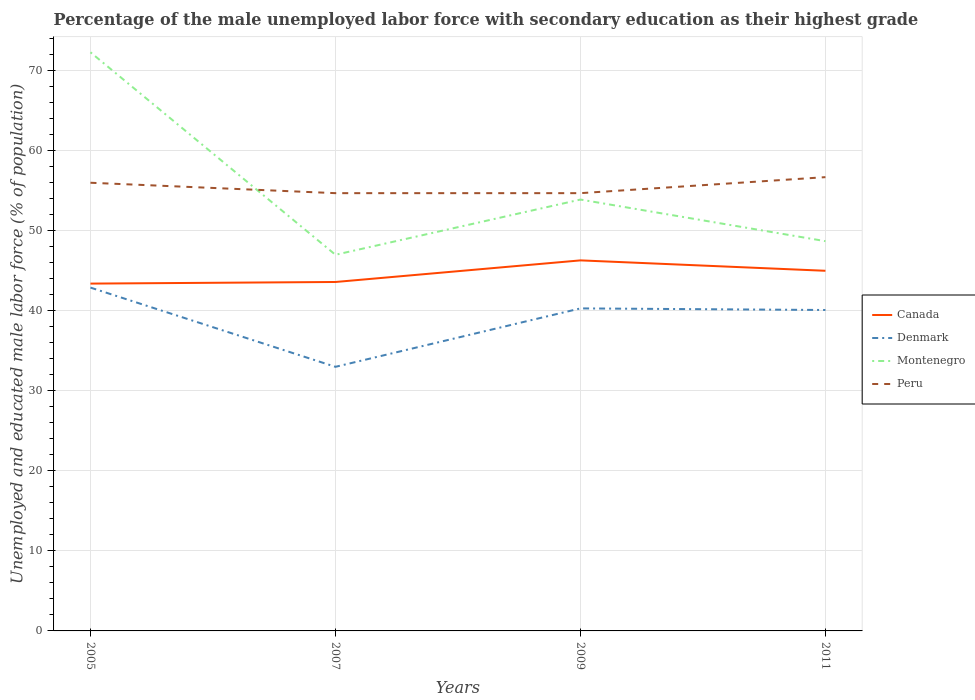Does the line corresponding to Denmark intersect with the line corresponding to Canada?
Give a very brief answer. No. Across all years, what is the maximum percentage of the unemployed male labor force with secondary education in Canada?
Your answer should be compact. 43.4. What is the total percentage of the unemployed male labor force with secondary education in Denmark in the graph?
Offer a very short reply. -7.1. What is the difference between the highest and the second highest percentage of the unemployed male labor force with secondary education in Canada?
Your response must be concise. 2.9. What is the difference between the highest and the lowest percentage of the unemployed male labor force with secondary education in Canada?
Offer a terse response. 2. Is the percentage of the unemployed male labor force with secondary education in Denmark strictly greater than the percentage of the unemployed male labor force with secondary education in Peru over the years?
Your answer should be compact. Yes. How many lines are there?
Provide a short and direct response. 4. What is the difference between two consecutive major ticks on the Y-axis?
Your response must be concise. 10. Does the graph contain grids?
Your answer should be compact. Yes. How many legend labels are there?
Ensure brevity in your answer.  4. What is the title of the graph?
Provide a succinct answer. Percentage of the male unemployed labor force with secondary education as their highest grade. Does "Norway" appear as one of the legend labels in the graph?
Your answer should be compact. No. What is the label or title of the Y-axis?
Your answer should be compact. Unemployed and educated male labor force (% of population). What is the Unemployed and educated male labor force (% of population) of Canada in 2005?
Offer a terse response. 43.4. What is the Unemployed and educated male labor force (% of population) of Denmark in 2005?
Your response must be concise. 42.9. What is the Unemployed and educated male labor force (% of population) of Montenegro in 2005?
Offer a very short reply. 72.3. What is the Unemployed and educated male labor force (% of population) in Canada in 2007?
Keep it short and to the point. 43.6. What is the Unemployed and educated male labor force (% of population) of Denmark in 2007?
Your response must be concise. 33. What is the Unemployed and educated male labor force (% of population) in Montenegro in 2007?
Give a very brief answer. 47. What is the Unemployed and educated male labor force (% of population) of Peru in 2007?
Your answer should be very brief. 54.7. What is the Unemployed and educated male labor force (% of population) in Canada in 2009?
Your answer should be very brief. 46.3. What is the Unemployed and educated male labor force (% of population) of Denmark in 2009?
Your answer should be compact. 40.3. What is the Unemployed and educated male labor force (% of population) of Montenegro in 2009?
Give a very brief answer. 53.9. What is the Unemployed and educated male labor force (% of population) in Peru in 2009?
Make the answer very short. 54.7. What is the Unemployed and educated male labor force (% of population) in Denmark in 2011?
Offer a terse response. 40.1. What is the Unemployed and educated male labor force (% of population) of Montenegro in 2011?
Make the answer very short. 48.7. What is the Unemployed and educated male labor force (% of population) of Peru in 2011?
Make the answer very short. 56.7. Across all years, what is the maximum Unemployed and educated male labor force (% of population) in Canada?
Provide a succinct answer. 46.3. Across all years, what is the maximum Unemployed and educated male labor force (% of population) of Denmark?
Provide a short and direct response. 42.9. Across all years, what is the maximum Unemployed and educated male labor force (% of population) of Montenegro?
Your response must be concise. 72.3. Across all years, what is the maximum Unemployed and educated male labor force (% of population) of Peru?
Make the answer very short. 56.7. Across all years, what is the minimum Unemployed and educated male labor force (% of population) of Canada?
Provide a short and direct response. 43.4. Across all years, what is the minimum Unemployed and educated male labor force (% of population) in Denmark?
Make the answer very short. 33. Across all years, what is the minimum Unemployed and educated male labor force (% of population) in Montenegro?
Give a very brief answer. 47. Across all years, what is the minimum Unemployed and educated male labor force (% of population) of Peru?
Your answer should be very brief. 54.7. What is the total Unemployed and educated male labor force (% of population) in Canada in the graph?
Give a very brief answer. 178.3. What is the total Unemployed and educated male labor force (% of population) of Denmark in the graph?
Provide a succinct answer. 156.3. What is the total Unemployed and educated male labor force (% of population) in Montenegro in the graph?
Ensure brevity in your answer.  221.9. What is the total Unemployed and educated male labor force (% of population) of Peru in the graph?
Your response must be concise. 222.1. What is the difference between the Unemployed and educated male labor force (% of population) of Canada in 2005 and that in 2007?
Your answer should be very brief. -0.2. What is the difference between the Unemployed and educated male labor force (% of population) in Denmark in 2005 and that in 2007?
Offer a very short reply. 9.9. What is the difference between the Unemployed and educated male labor force (% of population) of Montenegro in 2005 and that in 2007?
Provide a succinct answer. 25.3. What is the difference between the Unemployed and educated male labor force (% of population) in Canada in 2005 and that in 2009?
Your response must be concise. -2.9. What is the difference between the Unemployed and educated male labor force (% of population) in Denmark in 2005 and that in 2009?
Ensure brevity in your answer.  2.6. What is the difference between the Unemployed and educated male labor force (% of population) of Montenegro in 2005 and that in 2009?
Provide a short and direct response. 18.4. What is the difference between the Unemployed and educated male labor force (% of population) in Peru in 2005 and that in 2009?
Ensure brevity in your answer.  1.3. What is the difference between the Unemployed and educated male labor force (% of population) of Canada in 2005 and that in 2011?
Offer a very short reply. -1.6. What is the difference between the Unemployed and educated male labor force (% of population) of Denmark in 2005 and that in 2011?
Provide a short and direct response. 2.8. What is the difference between the Unemployed and educated male labor force (% of population) of Montenegro in 2005 and that in 2011?
Your answer should be compact. 23.6. What is the difference between the Unemployed and educated male labor force (% of population) in Canada in 2007 and that in 2009?
Your answer should be compact. -2.7. What is the difference between the Unemployed and educated male labor force (% of population) of Peru in 2007 and that in 2009?
Provide a succinct answer. 0. What is the difference between the Unemployed and educated male labor force (% of population) of Denmark in 2007 and that in 2011?
Your response must be concise. -7.1. What is the difference between the Unemployed and educated male labor force (% of population) in Montenegro in 2007 and that in 2011?
Your response must be concise. -1.7. What is the difference between the Unemployed and educated male labor force (% of population) in Montenegro in 2009 and that in 2011?
Offer a very short reply. 5.2. What is the difference between the Unemployed and educated male labor force (% of population) in Peru in 2009 and that in 2011?
Give a very brief answer. -2. What is the difference between the Unemployed and educated male labor force (% of population) in Canada in 2005 and the Unemployed and educated male labor force (% of population) in Montenegro in 2007?
Your answer should be compact. -3.6. What is the difference between the Unemployed and educated male labor force (% of population) in Canada in 2005 and the Unemployed and educated male labor force (% of population) in Peru in 2007?
Keep it short and to the point. -11.3. What is the difference between the Unemployed and educated male labor force (% of population) in Montenegro in 2005 and the Unemployed and educated male labor force (% of population) in Peru in 2007?
Offer a terse response. 17.6. What is the difference between the Unemployed and educated male labor force (% of population) in Canada in 2005 and the Unemployed and educated male labor force (% of population) in Denmark in 2009?
Ensure brevity in your answer.  3.1. What is the difference between the Unemployed and educated male labor force (% of population) in Canada in 2005 and the Unemployed and educated male labor force (% of population) in Montenegro in 2009?
Offer a very short reply. -10.5. What is the difference between the Unemployed and educated male labor force (% of population) of Denmark in 2005 and the Unemployed and educated male labor force (% of population) of Montenegro in 2009?
Provide a succinct answer. -11. What is the difference between the Unemployed and educated male labor force (% of population) in Canada in 2005 and the Unemployed and educated male labor force (% of population) in Montenegro in 2011?
Your answer should be compact. -5.3. What is the difference between the Unemployed and educated male labor force (% of population) in Canada in 2005 and the Unemployed and educated male labor force (% of population) in Peru in 2011?
Your answer should be very brief. -13.3. What is the difference between the Unemployed and educated male labor force (% of population) in Montenegro in 2005 and the Unemployed and educated male labor force (% of population) in Peru in 2011?
Your answer should be compact. 15.6. What is the difference between the Unemployed and educated male labor force (% of population) of Canada in 2007 and the Unemployed and educated male labor force (% of population) of Montenegro in 2009?
Offer a terse response. -10.3. What is the difference between the Unemployed and educated male labor force (% of population) of Denmark in 2007 and the Unemployed and educated male labor force (% of population) of Montenegro in 2009?
Offer a very short reply. -20.9. What is the difference between the Unemployed and educated male labor force (% of population) in Denmark in 2007 and the Unemployed and educated male labor force (% of population) in Peru in 2009?
Provide a succinct answer. -21.7. What is the difference between the Unemployed and educated male labor force (% of population) in Canada in 2007 and the Unemployed and educated male labor force (% of population) in Denmark in 2011?
Provide a short and direct response. 3.5. What is the difference between the Unemployed and educated male labor force (% of population) in Denmark in 2007 and the Unemployed and educated male labor force (% of population) in Montenegro in 2011?
Your response must be concise. -15.7. What is the difference between the Unemployed and educated male labor force (% of population) in Denmark in 2007 and the Unemployed and educated male labor force (% of population) in Peru in 2011?
Provide a short and direct response. -23.7. What is the difference between the Unemployed and educated male labor force (% of population) in Canada in 2009 and the Unemployed and educated male labor force (% of population) in Peru in 2011?
Your answer should be very brief. -10.4. What is the difference between the Unemployed and educated male labor force (% of population) in Denmark in 2009 and the Unemployed and educated male labor force (% of population) in Peru in 2011?
Make the answer very short. -16.4. What is the average Unemployed and educated male labor force (% of population) in Canada per year?
Your answer should be compact. 44.58. What is the average Unemployed and educated male labor force (% of population) of Denmark per year?
Keep it short and to the point. 39.08. What is the average Unemployed and educated male labor force (% of population) of Montenegro per year?
Offer a terse response. 55.48. What is the average Unemployed and educated male labor force (% of population) of Peru per year?
Offer a terse response. 55.52. In the year 2005, what is the difference between the Unemployed and educated male labor force (% of population) of Canada and Unemployed and educated male labor force (% of population) of Denmark?
Your answer should be compact. 0.5. In the year 2005, what is the difference between the Unemployed and educated male labor force (% of population) of Canada and Unemployed and educated male labor force (% of population) of Montenegro?
Offer a terse response. -28.9. In the year 2005, what is the difference between the Unemployed and educated male labor force (% of population) in Canada and Unemployed and educated male labor force (% of population) in Peru?
Ensure brevity in your answer.  -12.6. In the year 2005, what is the difference between the Unemployed and educated male labor force (% of population) in Denmark and Unemployed and educated male labor force (% of population) in Montenegro?
Make the answer very short. -29.4. In the year 2005, what is the difference between the Unemployed and educated male labor force (% of population) of Denmark and Unemployed and educated male labor force (% of population) of Peru?
Your answer should be very brief. -13.1. In the year 2007, what is the difference between the Unemployed and educated male labor force (% of population) in Canada and Unemployed and educated male labor force (% of population) in Denmark?
Offer a very short reply. 10.6. In the year 2007, what is the difference between the Unemployed and educated male labor force (% of population) of Canada and Unemployed and educated male labor force (% of population) of Montenegro?
Your answer should be compact. -3.4. In the year 2007, what is the difference between the Unemployed and educated male labor force (% of population) of Denmark and Unemployed and educated male labor force (% of population) of Peru?
Ensure brevity in your answer.  -21.7. In the year 2007, what is the difference between the Unemployed and educated male labor force (% of population) in Montenegro and Unemployed and educated male labor force (% of population) in Peru?
Offer a very short reply. -7.7. In the year 2009, what is the difference between the Unemployed and educated male labor force (% of population) in Canada and Unemployed and educated male labor force (% of population) in Montenegro?
Offer a terse response. -7.6. In the year 2009, what is the difference between the Unemployed and educated male labor force (% of population) in Canada and Unemployed and educated male labor force (% of population) in Peru?
Your answer should be compact. -8.4. In the year 2009, what is the difference between the Unemployed and educated male labor force (% of population) in Denmark and Unemployed and educated male labor force (% of population) in Montenegro?
Your answer should be very brief. -13.6. In the year 2009, what is the difference between the Unemployed and educated male labor force (% of population) in Denmark and Unemployed and educated male labor force (% of population) in Peru?
Your answer should be very brief. -14.4. In the year 2011, what is the difference between the Unemployed and educated male labor force (% of population) in Canada and Unemployed and educated male labor force (% of population) in Denmark?
Ensure brevity in your answer.  4.9. In the year 2011, what is the difference between the Unemployed and educated male labor force (% of population) of Canada and Unemployed and educated male labor force (% of population) of Peru?
Offer a very short reply. -11.7. In the year 2011, what is the difference between the Unemployed and educated male labor force (% of population) of Denmark and Unemployed and educated male labor force (% of population) of Peru?
Make the answer very short. -16.6. What is the ratio of the Unemployed and educated male labor force (% of population) in Denmark in 2005 to that in 2007?
Offer a very short reply. 1.3. What is the ratio of the Unemployed and educated male labor force (% of population) of Montenegro in 2005 to that in 2007?
Your answer should be compact. 1.54. What is the ratio of the Unemployed and educated male labor force (% of population) in Peru in 2005 to that in 2007?
Keep it short and to the point. 1.02. What is the ratio of the Unemployed and educated male labor force (% of population) of Canada in 2005 to that in 2009?
Provide a succinct answer. 0.94. What is the ratio of the Unemployed and educated male labor force (% of population) of Denmark in 2005 to that in 2009?
Keep it short and to the point. 1.06. What is the ratio of the Unemployed and educated male labor force (% of population) of Montenegro in 2005 to that in 2009?
Provide a succinct answer. 1.34. What is the ratio of the Unemployed and educated male labor force (% of population) in Peru in 2005 to that in 2009?
Give a very brief answer. 1.02. What is the ratio of the Unemployed and educated male labor force (% of population) in Canada in 2005 to that in 2011?
Provide a succinct answer. 0.96. What is the ratio of the Unemployed and educated male labor force (% of population) of Denmark in 2005 to that in 2011?
Offer a terse response. 1.07. What is the ratio of the Unemployed and educated male labor force (% of population) in Montenegro in 2005 to that in 2011?
Make the answer very short. 1.48. What is the ratio of the Unemployed and educated male labor force (% of population) of Peru in 2005 to that in 2011?
Give a very brief answer. 0.99. What is the ratio of the Unemployed and educated male labor force (% of population) of Canada in 2007 to that in 2009?
Provide a short and direct response. 0.94. What is the ratio of the Unemployed and educated male labor force (% of population) in Denmark in 2007 to that in 2009?
Your response must be concise. 0.82. What is the ratio of the Unemployed and educated male labor force (% of population) in Montenegro in 2007 to that in 2009?
Provide a short and direct response. 0.87. What is the ratio of the Unemployed and educated male labor force (% of population) of Canada in 2007 to that in 2011?
Provide a succinct answer. 0.97. What is the ratio of the Unemployed and educated male labor force (% of population) of Denmark in 2007 to that in 2011?
Your response must be concise. 0.82. What is the ratio of the Unemployed and educated male labor force (% of population) in Montenegro in 2007 to that in 2011?
Offer a very short reply. 0.97. What is the ratio of the Unemployed and educated male labor force (% of population) of Peru in 2007 to that in 2011?
Keep it short and to the point. 0.96. What is the ratio of the Unemployed and educated male labor force (% of population) of Canada in 2009 to that in 2011?
Offer a terse response. 1.03. What is the ratio of the Unemployed and educated male labor force (% of population) of Montenegro in 2009 to that in 2011?
Provide a succinct answer. 1.11. What is the ratio of the Unemployed and educated male labor force (% of population) in Peru in 2009 to that in 2011?
Your answer should be very brief. 0.96. What is the difference between the highest and the second highest Unemployed and educated male labor force (% of population) of Canada?
Provide a succinct answer. 1.3. What is the difference between the highest and the second highest Unemployed and educated male labor force (% of population) in Denmark?
Provide a succinct answer. 2.6. What is the difference between the highest and the second highest Unemployed and educated male labor force (% of population) of Montenegro?
Ensure brevity in your answer.  18.4. What is the difference between the highest and the lowest Unemployed and educated male labor force (% of population) of Canada?
Make the answer very short. 2.9. What is the difference between the highest and the lowest Unemployed and educated male labor force (% of population) of Montenegro?
Offer a very short reply. 25.3. What is the difference between the highest and the lowest Unemployed and educated male labor force (% of population) of Peru?
Ensure brevity in your answer.  2. 